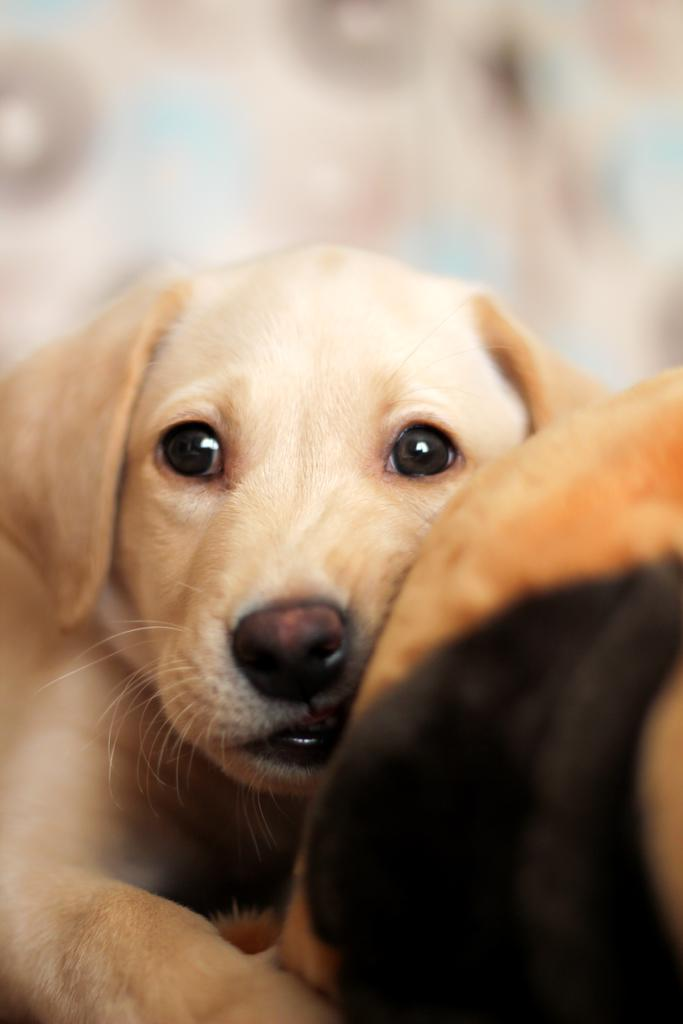What type of animal is in the image? There is a white dog in the image. Can you describe the background of the image? The background of the image is blurred. What thoughts does the secretary have while looking at the dog in the image? There is no secretary present in the image, so it is not possible to determine their thoughts. 